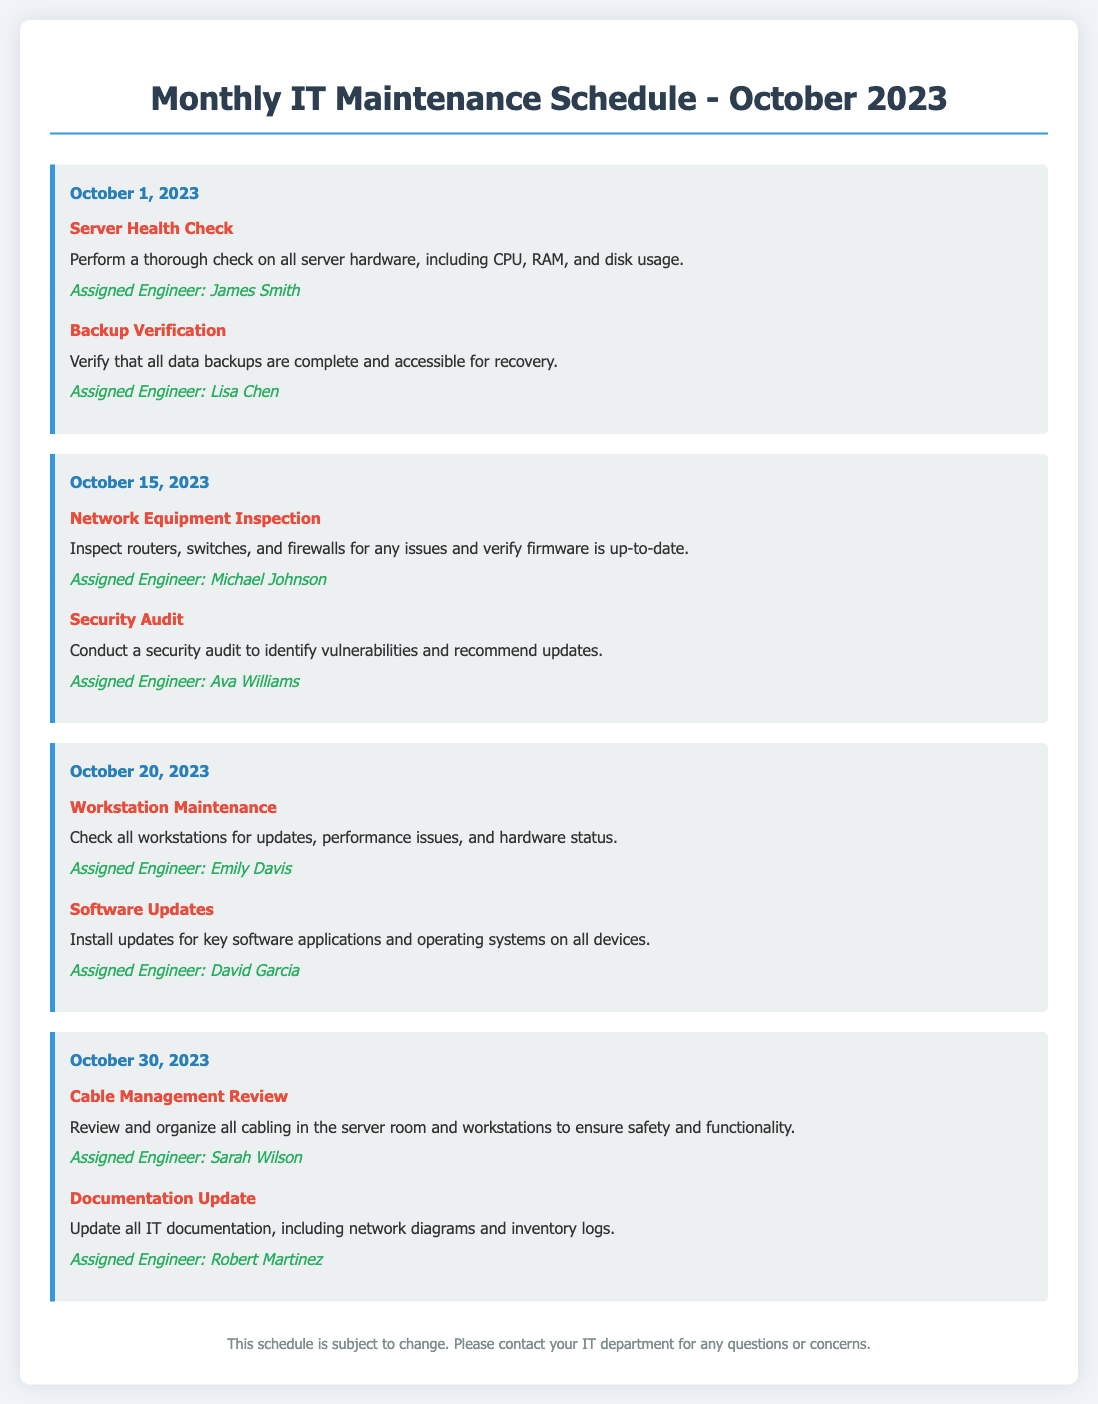what is the date of the Server Health Check? The Server Health Check is scheduled for October 1, 2023, according to the document.
Answer: October 1, 2023 who is assigned to perform the Backup Verification? The assigned engineer for the Backup Verification task is Lisa Chen.
Answer: Lisa Chen how many tasks are scheduled for October 20, 2023? There are two tasks scheduled on October 20, 2023.
Answer: 2 what is the task scheduled for October 15, 2023? The tasks scheduled for October 15, 2023, are Network Equipment Inspection and Security Audit.
Answer: Network Equipment Inspection, Security Audit who is responsible for the Documentation Update? The engineer assigned to the Documentation Update task is Robert Martinez.
Answer: Robert Martinez what type of maintenance is scheduled for workstations? The scheduled maintenance for workstations is referred to as Workstation Maintenance.
Answer: Workstation Maintenance what is the main purpose of the schedule? The main purpose of the schedule is to outline monthly IT maintenance tasks for proper infrastructure management.
Answer: outline monthly IT maintenance tasks how does the document categorize tasks? The document categorizes tasks by listing the date, task name, description, and assigned engineer.
Answer: by date, task name, description, and assigned engineer 